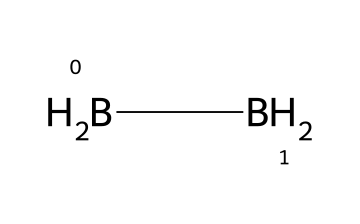What is the molecular formula of diborane? The SMILES representation shows two boron atoms and four hydrogen atoms. Therefore, the molecular formula can be derived as B2H6.
Answer: B2H6 How many hydrogen atoms are in diborane? From the SMILES notation, we can count that there are four hydrogen atoms attached to the boron atoms.
Answer: 4 What type of bonding is present in diborane? The structure indicates a combination of conventional covalent bonds and unique three-center two-electron bonds. These types of bonding are typical for boranes, especially in diborane.
Answer: covalent How many total atoms are present in diborane? Counting the atoms from the formula B2H6, we have two boron atoms and six hydrogen atoms, totaling eight atoms.
Answer: 8 What is the coordination geometry around the boron atoms in diborane? Based on the structure, the boron atoms in diborane adopt a trigonal planar geometry due to their bonding with hydrogen atoms and the unique three-center two-electron bond.
Answer: trigonal planar What type of chemical is diborane considered? Diborane is classified as a borane, which is a specific type of compound that contains boron and hydrogen in defined stoichiometric ratios.
Answer: borane How do the boron atoms in diborane contribute to its reactivity? The three-center two-electron bond makes diborane more reactive than typical hydrocarbons, allowing it to participate in various chemical reactions, especially in the presence of electron-rich species.
Answer: reactivity 